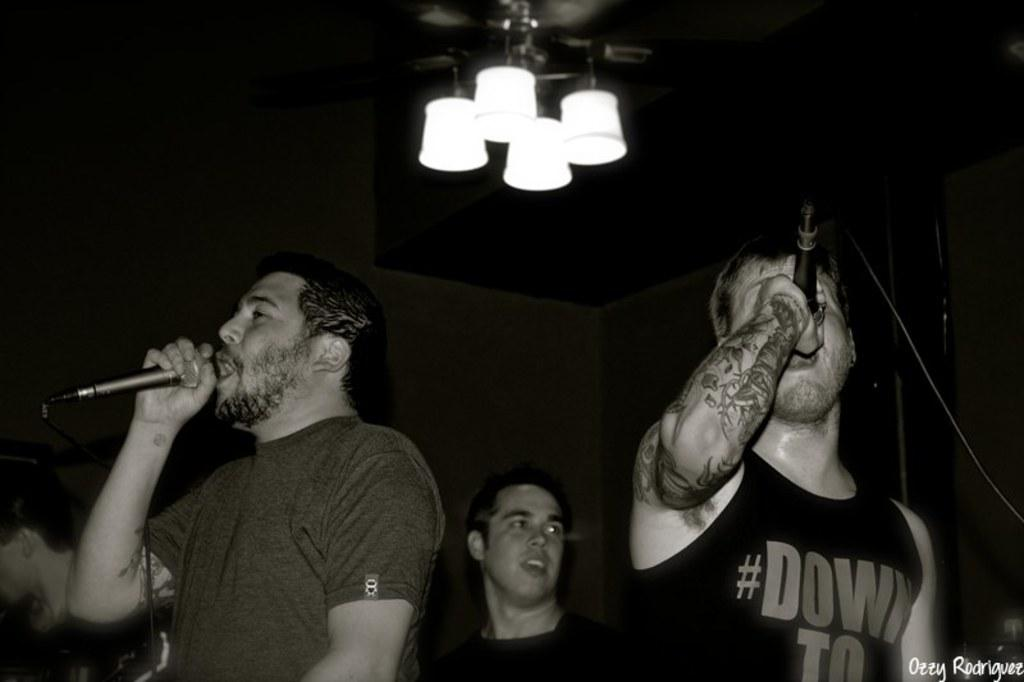How many people are in the image? There are two persons in the image. What are the two persons holding in their hands? The two persons are holding microphones in their hands. What are the two persons doing with the microphones? The two persons are singing. Can you describe the background of the image? There are two other persons in the background. What can be seen in the top part of the image? There are lights visible in the top part of the image. What type of cabbage is being used as a prop by one of the singers in the image? There is no cabbage present in the image; the two persons are holding microphones and singing. 